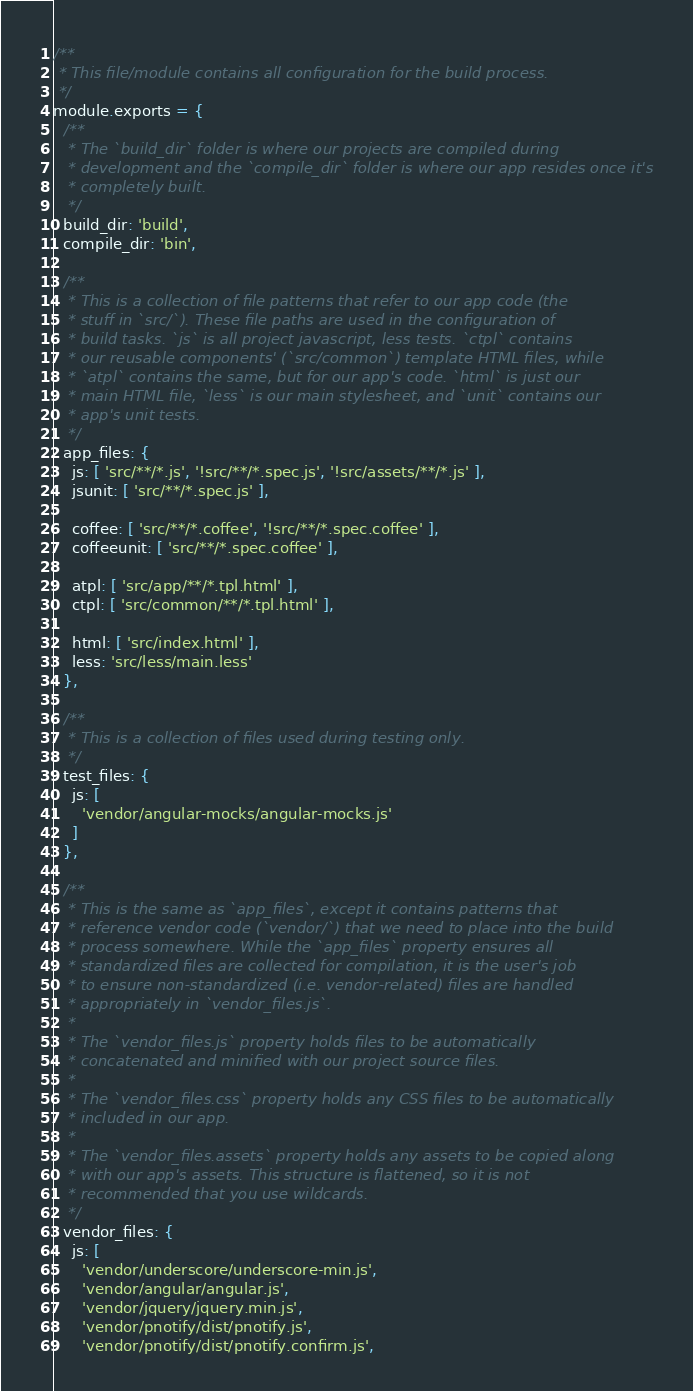<code> <loc_0><loc_0><loc_500><loc_500><_JavaScript_>/**
 * This file/module contains all configuration for the build process.
 */
module.exports = {
  /**
   * The `build_dir` folder is where our projects are compiled during
   * development and the `compile_dir` folder is where our app resides once it's
   * completely built.
   */
  build_dir: 'build',
  compile_dir: 'bin',

  /**
   * This is a collection of file patterns that refer to our app code (the
   * stuff in `src/`). These file paths are used in the configuration of
   * build tasks. `js` is all project javascript, less tests. `ctpl` contains
   * our reusable components' (`src/common`) template HTML files, while
   * `atpl` contains the same, but for our app's code. `html` is just our
   * main HTML file, `less` is our main stylesheet, and `unit` contains our
   * app's unit tests.
   */
  app_files: {
    js: [ 'src/**/*.js', '!src/**/*.spec.js', '!src/assets/**/*.js' ],
    jsunit: [ 'src/**/*.spec.js' ],
    
    coffee: [ 'src/**/*.coffee', '!src/**/*.spec.coffee' ],
    coffeeunit: [ 'src/**/*.spec.coffee' ],

    atpl: [ 'src/app/**/*.tpl.html' ],
    ctpl: [ 'src/common/**/*.tpl.html' ],

    html: [ 'src/index.html' ],
    less: 'src/less/main.less'
  },

  /**
   * This is a collection of files used during testing only.
   */
  test_files: {
    js: [
      'vendor/angular-mocks/angular-mocks.js'
    ]
  },

  /**
   * This is the same as `app_files`, except it contains patterns that
   * reference vendor code (`vendor/`) that we need to place into the build
   * process somewhere. While the `app_files` property ensures all
   * standardized files are collected for compilation, it is the user's job
   * to ensure non-standardized (i.e. vendor-related) files are handled
   * appropriately in `vendor_files.js`.
   *
   * The `vendor_files.js` property holds files to be automatically
   * concatenated and minified with our project source files.
   *
   * The `vendor_files.css` property holds any CSS files to be automatically
   * included in our app.
   *
   * The `vendor_files.assets` property holds any assets to be copied along
   * with our app's assets. This structure is flattened, so it is not
   * recommended that you use wildcards.
   */
  vendor_files: {
    js: [
      'vendor/underscore/underscore-min.js',
      'vendor/angular/angular.js',
      'vendor/jquery/jquery.min.js',
      'vendor/pnotify/dist/pnotify.js',
      'vendor/pnotify/dist/pnotify.confirm.js',</code> 